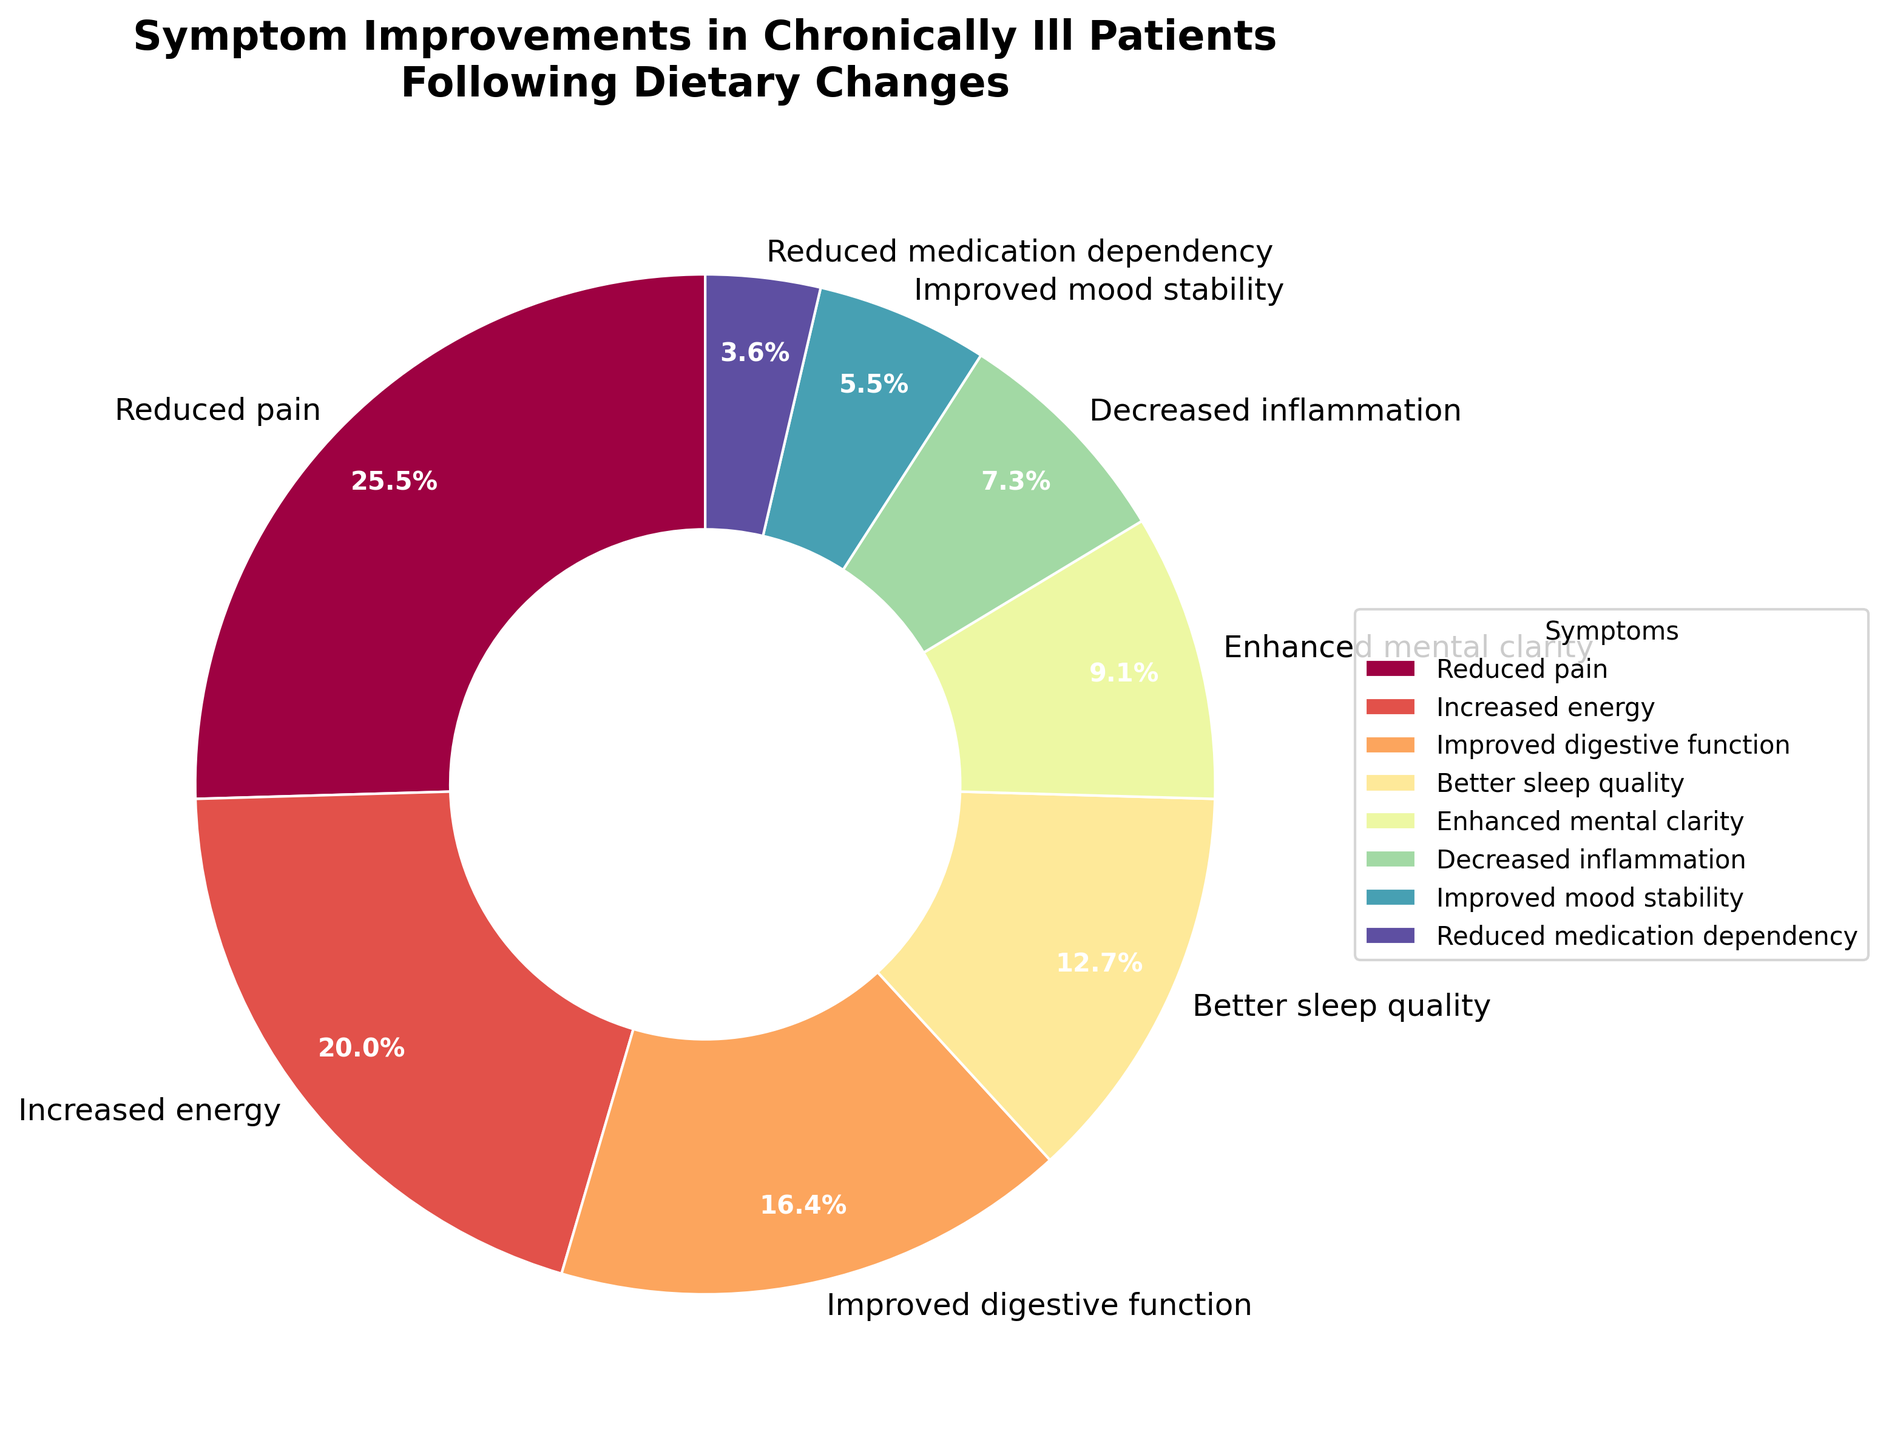What symptom shows the highest improvement percentage in patients following dietary changes? The largest segment of the pie chart represents the "Reduced pain" symptom, which occupies 28% of the chart. This indicates that "Reduced pain" is the symptom with the highest improvement percentage among the patients.
Answer: Reduced pain Which symptom has the second largest improvement percentage? The second largest segment in the pie chart corresponds to "Increased energy," which covers 22% of the chart. This means "Increased energy" has the second largest improvement percentage.
Answer: Increased energy What is the total percentage of improved digestive function and better sleep quality? To find the total percentage, we sum the percentages for "Improved digestive function" (18%) and "Better sleep quality" (14%). This gives us 18% + 14% = 32%.
Answer: 32% Which symptom has a smaller improvement percentage: reduced medication dependency or improved mood stability? Comparing the segments, "Reduced medication dependency" has a percentage of 4%, while "Improved mood stability" has a percentage of 6%. Therefore, "Reduced medication dependency" has a smaller improvement percentage.
Answer: Reduced medication dependency What is the combined percentage of improvements in pain, energy, and digestion? The combined percentage is the sum of "Reduced pain" (28%), "Increased energy" (22%), and "Improved digestive function" (18%). Adding them together gives 28% + 22% + 18% = 68%.
Answer: 68% Which has a greater percentage of improvement, enhanced mental clarity or decreased inflammation? The pie chart shows that "Enhanced mental clarity" has a percentage of 10%, whereas "Decreased inflammation" has a percentage of 8%. Therefore, "Enhanced mental clarity" has a greater percentage of improvement.
Answer: Enhanced mental clarity Are there more patients reporting improvements in pain or sleep quality? The pie chart indicates that "Reduced pain" has a percentage of 28%, whereas "Better sleep quality" has a percentage of 14%. Therefore, more patients report improvements in pain.
Answer: Reduced pain What is the difference in percentage between improved mood stability and reduced medication dependency? The percentage for "Improved mood stability" is 6%, while for "Reduced medication dependency" it is 4%. The difference is 6% - 4% = 2%.
Answer: 2% Which symptom improvement accounts for the smallest percentage? The smallest segment corresponds to "Reduced medication dependency," which covers 4% of the pie chart.
Answer: Reduced medication dependency 